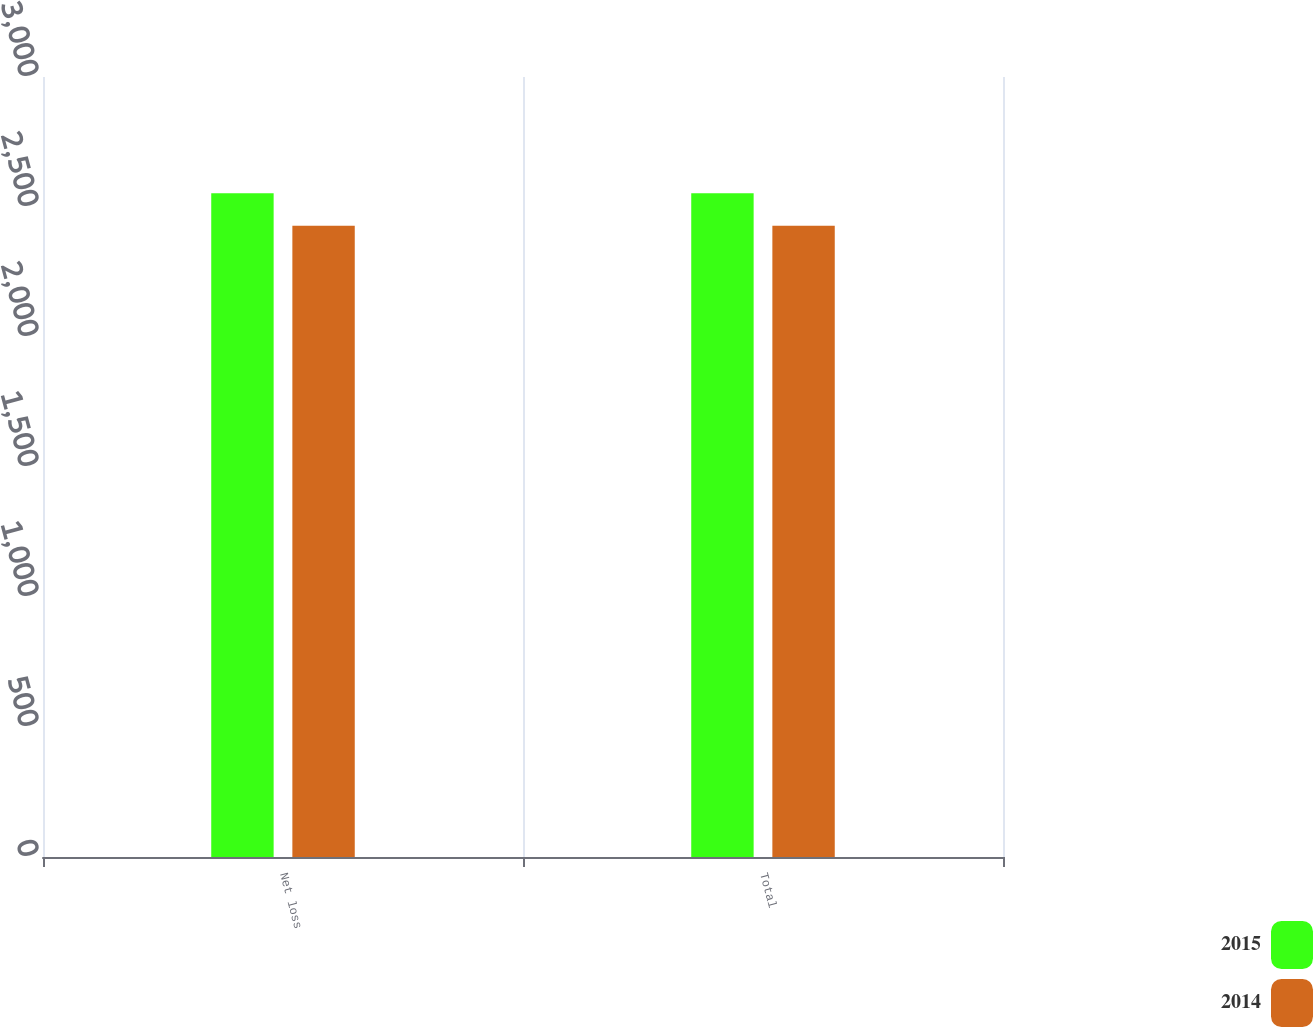<chart> <loc_0><loc_0><loc_500><loc_500><stacked_bar_chart><ecel><fcel>Net loss<fcel>Total<nl><fcel>2015<fcel>2553<fcel>2553<nl><fcel>2014<fcel>2428<fcel>2428<nl></chart> 